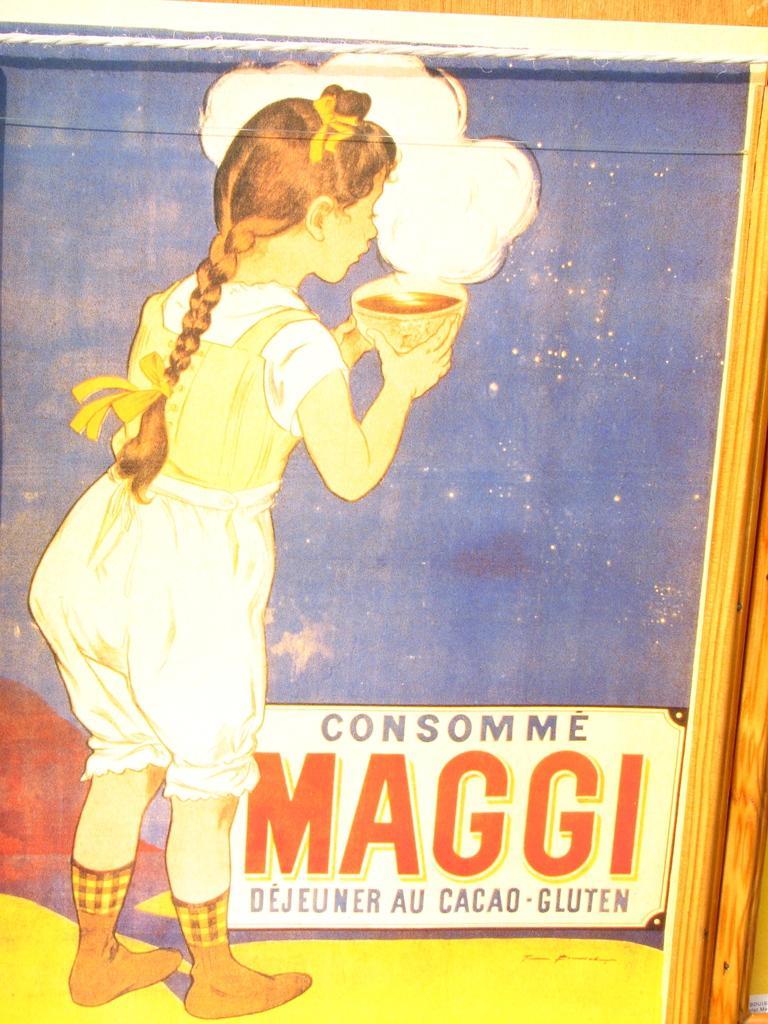Describe this image in one or two sentences. In this image I can see a photo frame. There is an image of a girl holding a bowl. There is a board below her. 